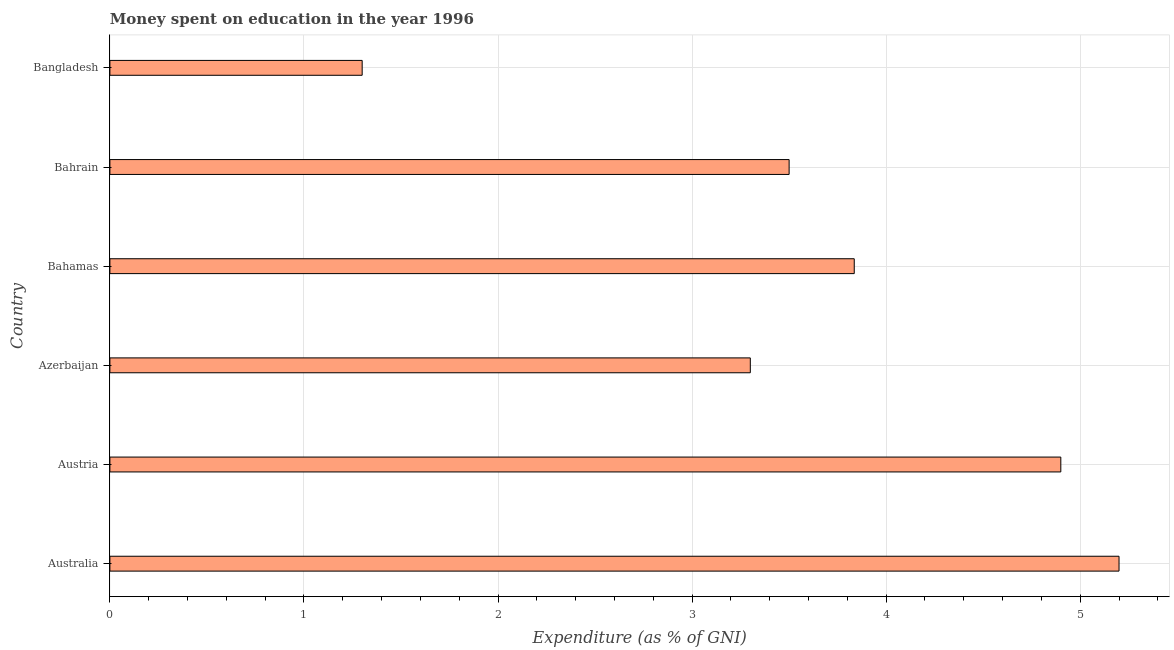Does the graph contain any zero values?
Give a very brief answer. No. What is the title of the graph?
Offer a very short reply. Money spent on education in the year 1996. What is the label or title of the X-axis?
Ensure brevity in your answer.  Expenditure (as % of GNI). Across all countries, what is the maximum expenditure on education?
Your answer should be compact. 5.2. In which country was the expenditure on education minimum?
Ensure brevity in your answer.  Bangladesh. What is the sum of the expenditure on education?
Give a very brief answer. 22.04. What is the average expenditure on education per country?
Offer a terse response. 3.67. What is the median expenditure on education?
Your response must be concise. 3.67. What is the ratio of the expenditure on education in Australia to that in Bahrain?
Make the answer very short. 1.49. Is the difference between the expenditure on education in Azerbaijan and Bahamas greater than the difference between any two countries?
Your answer should be very brief. No. What is the difference between the highest and the lowest expenditure on education?
Offer a terse response. 3.9. How many bars are there?
Your response must be concise. 6. Are all the bars in the graph horizontal?
Make the answer very short. Yes. How many countries are there in the graph?
Provide a short and direct response. 6. What is the difference between two consecutive major ticks on the X-axis?
Provide a short and direct response. 1. Are the values on the major ticks of X-axis written in scientific E-notation?
Offer a very short reply. No. What is the Expenditure (as % of GNI) in Azerbaijan?
Provide a succinct answer. 3.3. What is the Expenditure (as % of GNI) of Bahamas?
Your answer should be very brief. 3.84. What is the Expenditure (as % of GNI) of Bahrain?
Give a very brief answer. 3.5. What is the difference between the Expenditure (as % of GNI) in Australia and Bahamas?
Ensure brevity in your answer.  1.36. What is the difference between the Expenditure (as % of GNI) in Austria and Azerbaijan?
Offer a terse response. 1.6. What is the difference between the Expenditure (as % of GNI) in Austria and Bahamas?
Offer a very short reply. 1.06. What is the difference between the Expenditure (as % of GNI) in Azerbaijan and Bahamas?
Your answer should be very brief. -0.54. What is the difference between the Expenditure (as % of GNI) in Bahamas and Bahrain?
Your answer should be very brief. 0.34. What is the difference between the Expenditure (as % of GNI) in Bahamas and Bangladesh?
Keep it short and to the point. 2.54. What is the difference between the Expenditure (as % of GNI) in Bahrain and Bangladesh?
Provide a succinct answer. 2.2. What is the ratio of the Expenditure (as % of GNI) in Australia to that in Austria?
Provide a succinct answer. 1.06. What is the ratio of the Expenditure (as % of GNI) in Australia to that in Azerbaijan?
Give a very brief answer. 1.58. What is the ratio of the Expenditure (as % of GNI) in Australia to that in Bahamas?
Make the answer very short. 1.36. What is the ratio of the Expenditure (as % of GNI) in Australia to that in Bahrain?
Your answer should be compact. 1.49. What is the ratio of the Expenditure (as % of GNI) in Austria to that in Azerbaijan?
Your answer should be compact. 1.49. What is the ratio of the Expenditure (as % of GNI) in Austria to that in Bahamas?
Keep it short and to the point. 1.28. What is the ratio of the Expenditure (as % of GNI) in Austria to that in Bahrain?
Give a very brief answer. 1.4. What is the ratio of the Expenditure (as % of GNI) in Austria to that in Bangladesh?
Give a very brief answer. 3.77. What is the ratio of the Expenditure (as % of GNI) in Azerbaijan to that in Bahamas?
Your response must be concise. 0.86. What is the ratio of the Expenditure (as % of GNI) in Azerbaijan to that in Bahrain?
Provide a succinct answer. 0.94. What is the ratio of the Expenditure (as % of GNI) in Azerbaijan to that in Bangladesh?
Offer a terse response. 2.54. What is the ratio of the Expenditure (as % of GNI) in Bahamas to that in Bahrain?
Make the answer very short. 1.1. What is the ratio of the Expenditure (as % of GNI) in Bahamas to that in Bangladesh?
Keep it short and to the point. 2.95. What is the ratio of the Expenditure (as % of GNI) in Bahrain to that in Bangladesh?
Your answer should be compact. 2.69. 